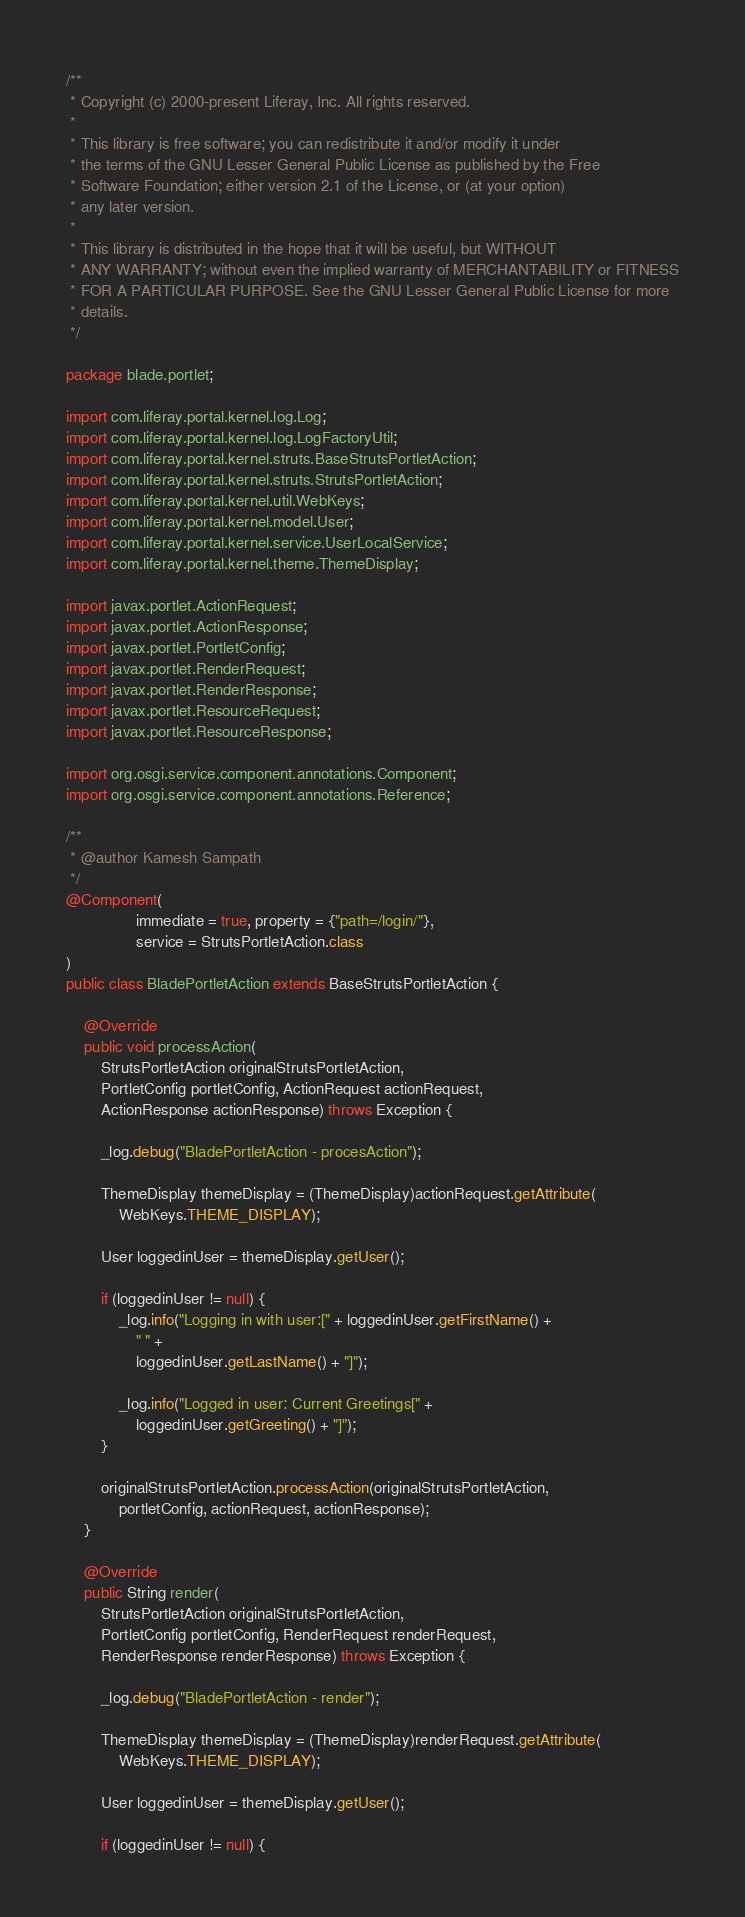Convert code to text. <code><loc_0><loc_0><loc_500><loc_500><_Java_>/**
 * Copyright (c) 2000-present Liferay, Inc. All rights reserved.
 *
 * This library is free software; you can redistribute it and/or modify it under
 * the terms of the GNU Lesser General Public License as published by the Free
 * Software Foundation; either version 2.1 of the License, or (at your option)
 * any later version.
 *
 * This library is distributed in the hope that it will be useful, but WITHOUT
 * ANY WARRANTY; without even the implied warranty of MERCHANTABILITY or FITNESS
 * FOR A PARTICULAR PURPOSE. See the GNU Lesser General Public License for more
 * details.
 */

package blade.portlet;

import com.liferay.portal.kernel.log.Log;
import com.liferay.portal.kernel.log.LogFactoryUtil;
import com.liferay.portal.kernel.struts.BaseStrutsPortletAction;
import com.liferay.portal.kernel.struts.StrutsPortletAction;
import com.liferay.portal.kernel.util.WebKeys;
import com.liferay.portal.kernel.model.User;
import com.liferay.portal.kernel.service.UserLocalService;
import com.liferay.portal.kernel.theme.ThemeDisplay;

import javax.portlet.ActionRequest;
import javax.portlet.ActionResponse;
import javax.portlet.PortletConfig;
import javax.portlet.RenderRequest;
import javax.portlet.RenderResponse;
import javax.portlet.ResourceRequest;
import javax.portlet.ResourceResponse;

import org.osgi.service.component.annotations.Component;
import org.osgi.service.component.annotations.Reference;

/**
 * @author Kamesh Sampath
 */
@Component(
				immediate = true, property = {"path=/login/"},
				service = StrutsPortletAction.class
)
public class BladePortletAction extends BaseStrutsPortletAction {

	@Override
	public void processAction(
		StrutsPortletAction originalStrutsPortletAction,
		PortletConfig portletConfig, ActionRequest actionRequest,
		ActionResponse actionResponse) throws Exception {

		_log.debug("BladePortletAction - procesAction");

		ThemeDisplay themeDisplay = (ThemeDisplay)actionRequest.getAttribute(
			WebKeys.THEME_DISPLAY);

		User loggedinUser = themeDisplay.getUser();

		if (loggedinUser != null) {
			_log.info("Logging in with user:[" + loggedinUser.getFirstName() +
				" " +
				loggedinUser.getLastName() + "]");

			_log.info("Logged in user: Current Greetings[" +
				loggedinUser.getGreeting() + "]");
		}

		originalStrutsPortletAction.processAction(originalStrutsPortletAction,
			portletConfig, actionRequest, actionResponse);
	}

	@Override
	public String render(
		StrutsPortletAction originalStrutsPortletAction,
		PortletConfig portletConfig, RenderRequest renderRequest,
		RenderResponse renderResponse) throws Exception {

		_log.debug("BladePortletAction - render");

		ThemeDisplay themeDisplay = (ThemeDisplay)renderRequest.getAttribute(
			WebKeys.THEME_DISPLAY);

		User loggedinUser = themeDisplay.getUser();

		if (loggedinUser != null) {</code> 